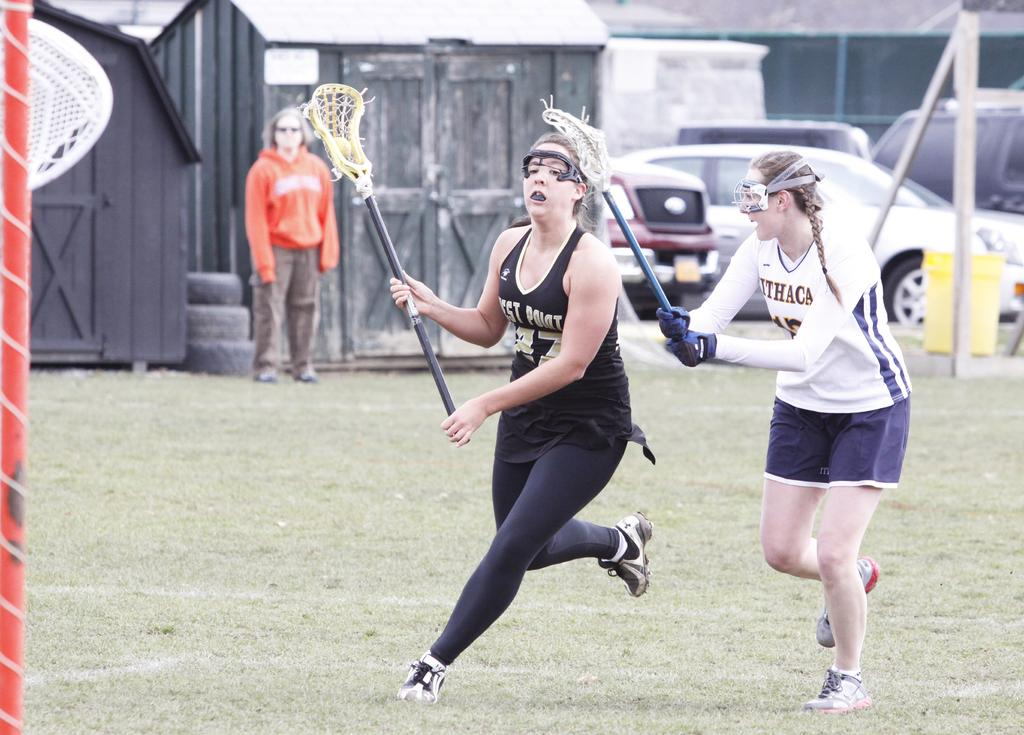What are the two women in the image doing? The two women in the image are playing lacrosse. Who else is present in the image besides the women playing lacrosse? There is a woman standing at the back and watching. What can be seen in the background of the image? Cars parked and a house are visible in the background. What statement does the father make about the roof in the image? There is no father present in the image, and therefore no statement can be made about the roof. 